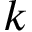<formula> <loc_0><loc_0><loc_500><loc_500>k</formula> 